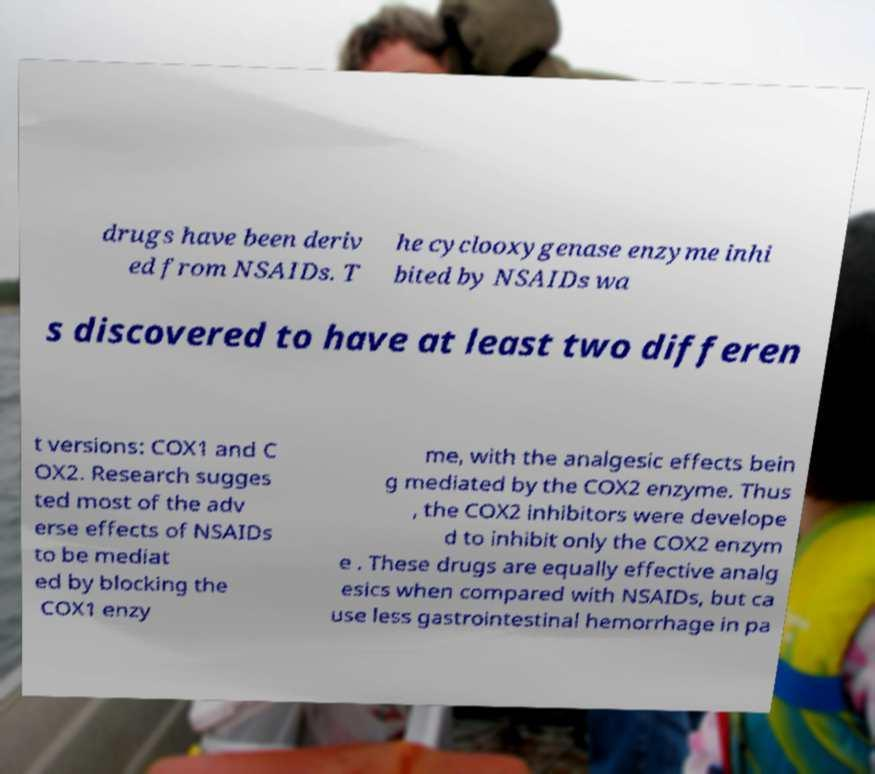Could you extract and type out the text from this image? drugs have been deriv ed from NSAIDs. T he cyclooxygenase enzyme inhi bited by NSAIDs wa s discovered to have at least two differen t versions: COX1 and C OX2. Research sugges ted most of the adv erse effects of NSAIDs to be mediat ed by blocking the COX1 enzy me, with the analgesic effects bein g mediated by the COX2 enzyme. Thus , the COX2 inhibitors were develope d to inhibit only the COX2 enzym e . These drugs are equally effective analg esics when compared with NSAIDs, but ca use less gastrointestinal hemorrhage in pa 